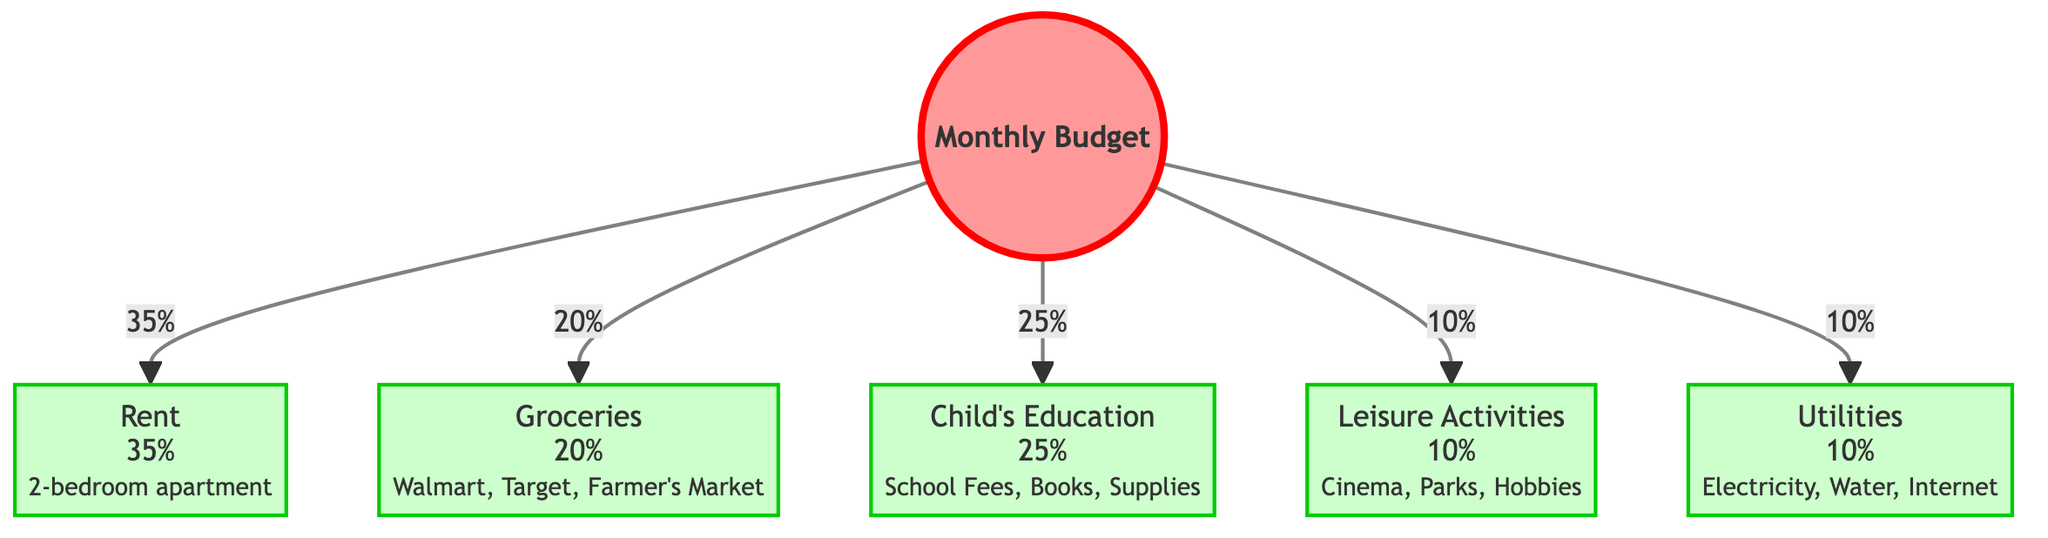What percentage of the budget is allocated for rent? The diagram specifies that rent is allocated 35% of the total monthly budget. This is directly indicated in the connection from the central node to the rent node.
Answer: 35% What are the categories of expenses shown in the diagram? The diagram includes five categories of expenses: Rent, Groceries, Child's Education, Leisure Activities, and Utilities. This information can be gathered from the labeled nodes connected to the central node.
Answer: Rent, Groceries, Child's Education, Leisure Activities, Utilities Which expense has the highest percentage allocation? Analyzing the percentage allocations, rent has the highest allocation at 35%. This is identified by comparing the values associated with each expense node.
Answer: Rent What is the total percentage of the budget allocated for leisure and groceries combined? By summing the percentages of leisure (10%) and groceries (20%), we get a total of 30%. This requires adding the values from the corresponding expense nodes.
Answer: 30% What percentage is allocated for utilities? The diagram indicates that 10% of the budget is allocated for utilities. This comes directly from the connection to the utilities node.
Answer: 10% If the total budget is $2000, how much is allocated for child’s education? The child's education is allocated 25% of the total budget. Calculating 25% of $2000 gives $500, derived by multiplying the total budget by 0.25 (2000 * 0.25).
Answer: $500 Which expense takes up one-tenth of the budget? Utilities, which is allocated at 10%, takes up one-tenth of the total budget. This is evident as the utilities node indicates a 10% allocation.
Answer: Utilities What is the combined percentage of education and leisure activities expenses? The percentages for education (25%) and leisure (10%) combined total 35%. This is found by adding the two percentages together (25% + 10%).
Answer: 35% 